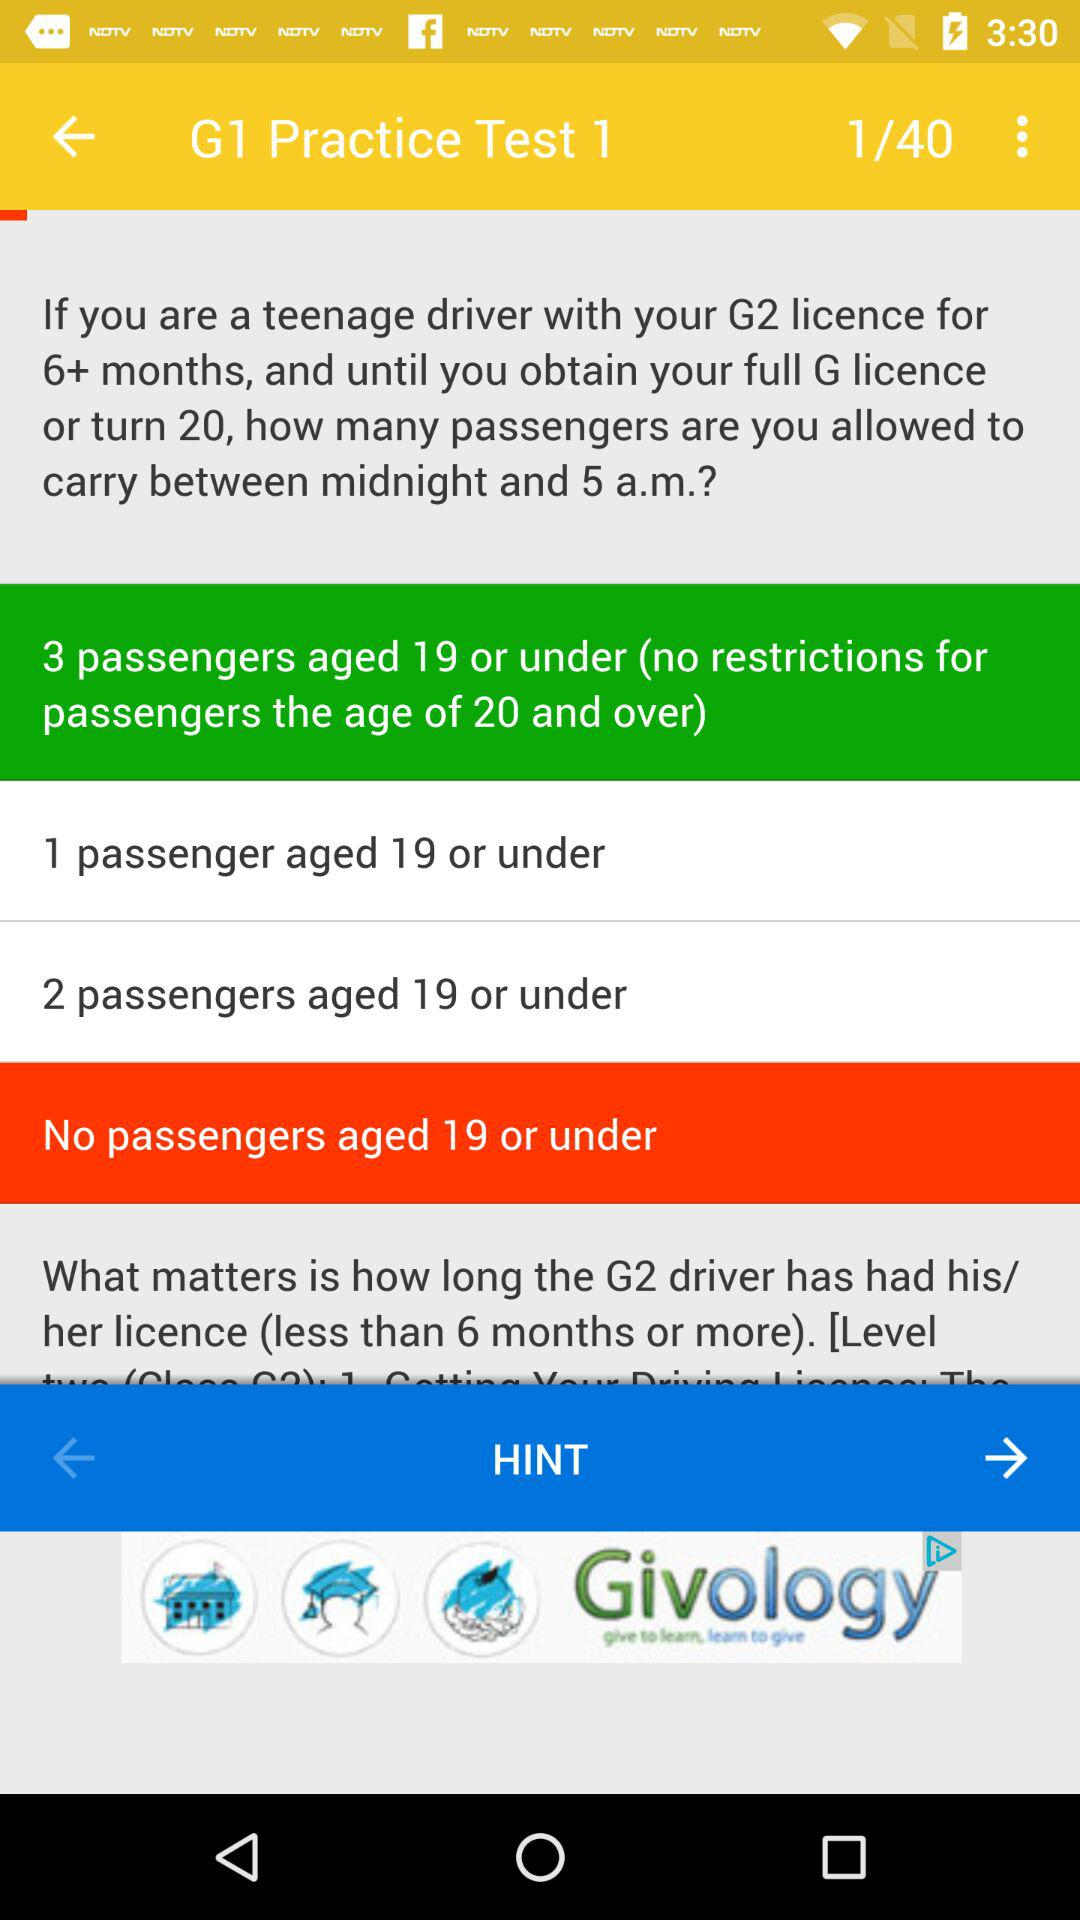How many passengers are aged 19?
When the provided information is insufficient, respond with <no answer>. <no answer> 